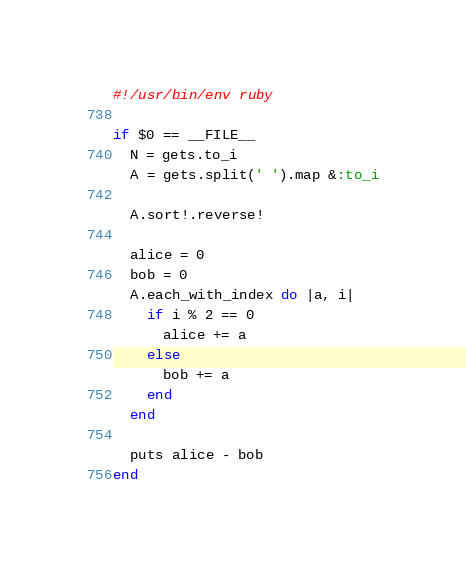Convert code to text. <code><loc_0><loc_0><loc_500><loc_500><_Ruby_>#!/usr/bin/env ruby

if $0 == __FILE__
  N = gets.to_i
  A = gets.split(' ').map &:to_i

  A.sort!.reverse!

  alice = 0
  bob = 0
  A.each_with_index do |a, i|
    if i % 2 == 0
      alice += a
    else
      bob += a
    end
  end

  puts alice - bob
end
</code> 